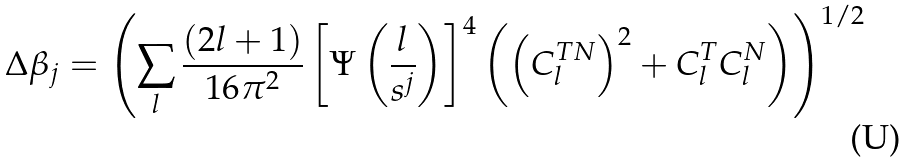Convert formula to latex. <formula><loc_0><loc_0><loc_500><loc_500>\Delta \beta _ { j } = \left ( \sum _ { l } \frac { ( 2 l + 1 ) } { 1 6 \pi ^ { 2 } } \left [ \Psi \left ( \frac { l } { s ^ { j } } \right ) \right ] ^ { 4 } \left ( \left ( C ^ { T N } _ { l } \right ) ^ { 2 } + C ^ { T } _ { l } C ^ { N } _ { l } \right ) \right ) ^ { 1 / 2 }</formula> 